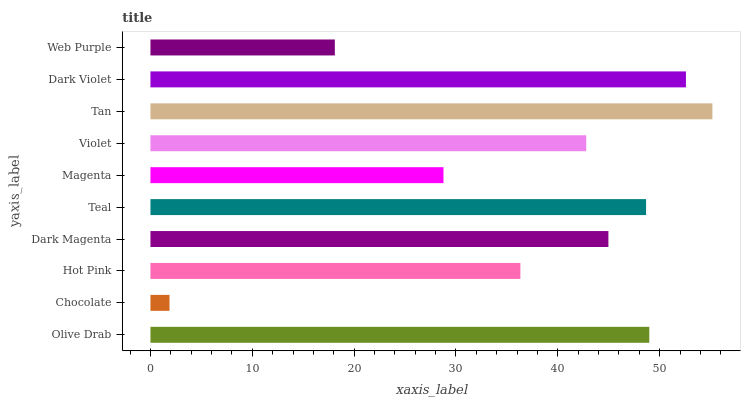Is Chocolate the minimum?
Answer yes or no. Yes. Is Tan the maximum?
Answer yes or no. Yes. Is Hot Pink the minimum?
Answer yes or no. No. Is Hot Pink the maximum?
Answer yes or no. No. Is Hot Pink greater than Chocolate?
Answer yes or no. Yes. Is Chocolate less than Hot Pink?
Answer yes or no. Yes. Is Chocolate greater than Hot Pink?
Answer yes or no. No. Is Hot Pink less than Chocolate?
Answer yes or no. No. Is Dark Magenta the high median?
Answer yes or no. Yes. Is Violet the low median?
Answer yes or no. Yes. Is Hot Pink the high median?
Answer yes or no. No. Is Web Purple the low median?
Answer yes or no. No. 